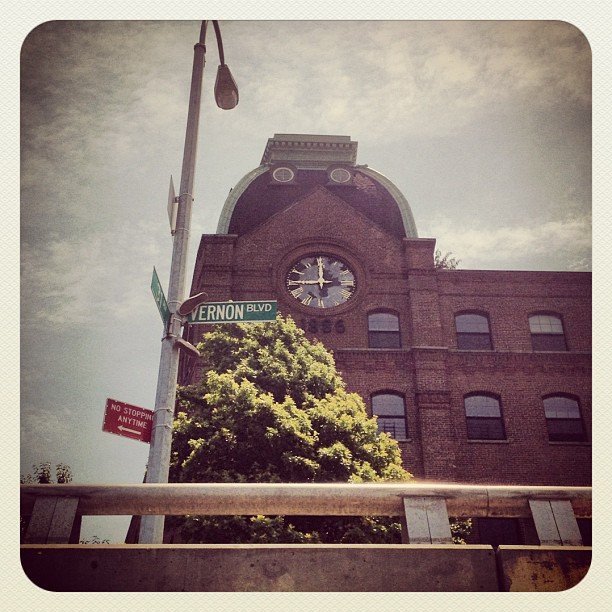Please extract the text content from this image. VERNON BLVD NO ANYTIME STOPPING 886 